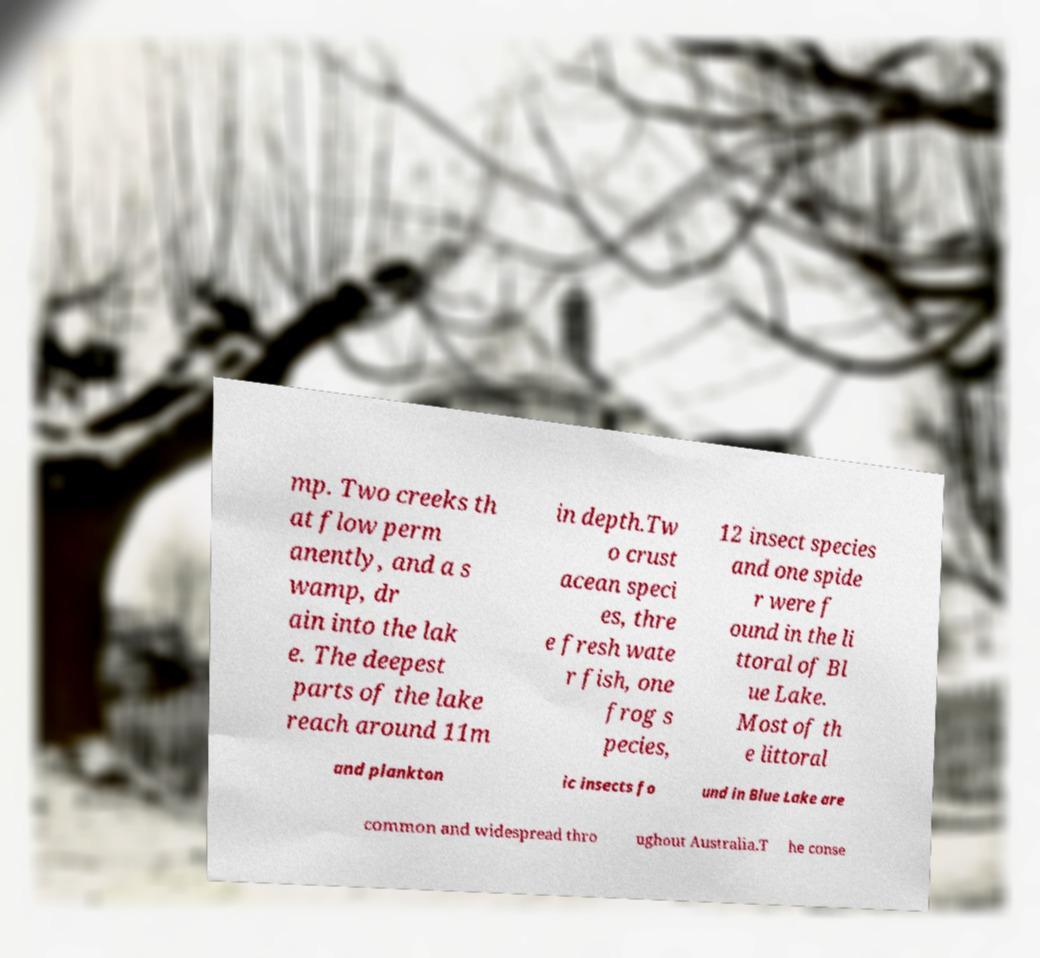I need the written content from this picture converted into text. Can you do that? mp. Two creeks th at flow perm anently, and a s wamp, dr ain into the lak e. The deepest parts of the lake reach around 11m in depth.Tw o crust acean speci es, thre e fresh wate r fish, one frog s pecies, 12 insect species and one spide r were f ound in the li ttoral of Bl ue Lake. Most of th e littoral and plankton ic insects fo und in Blue Lake are common and widespread thro ughout Australia.T he conse 